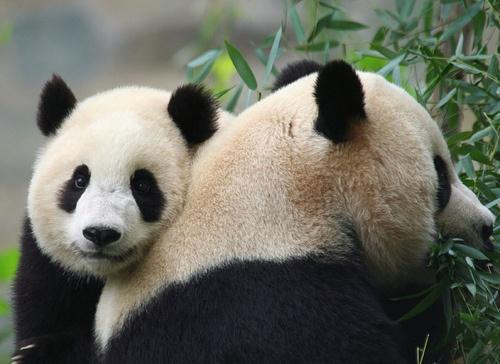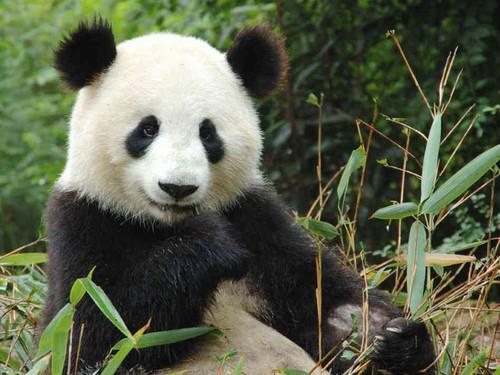The first image is the image on the left, the second image is the image on the right. Assess this claim about the two images: "In one of the images there are two pandas huddled together.". Correct or not? Answer yes or no. Yes. 